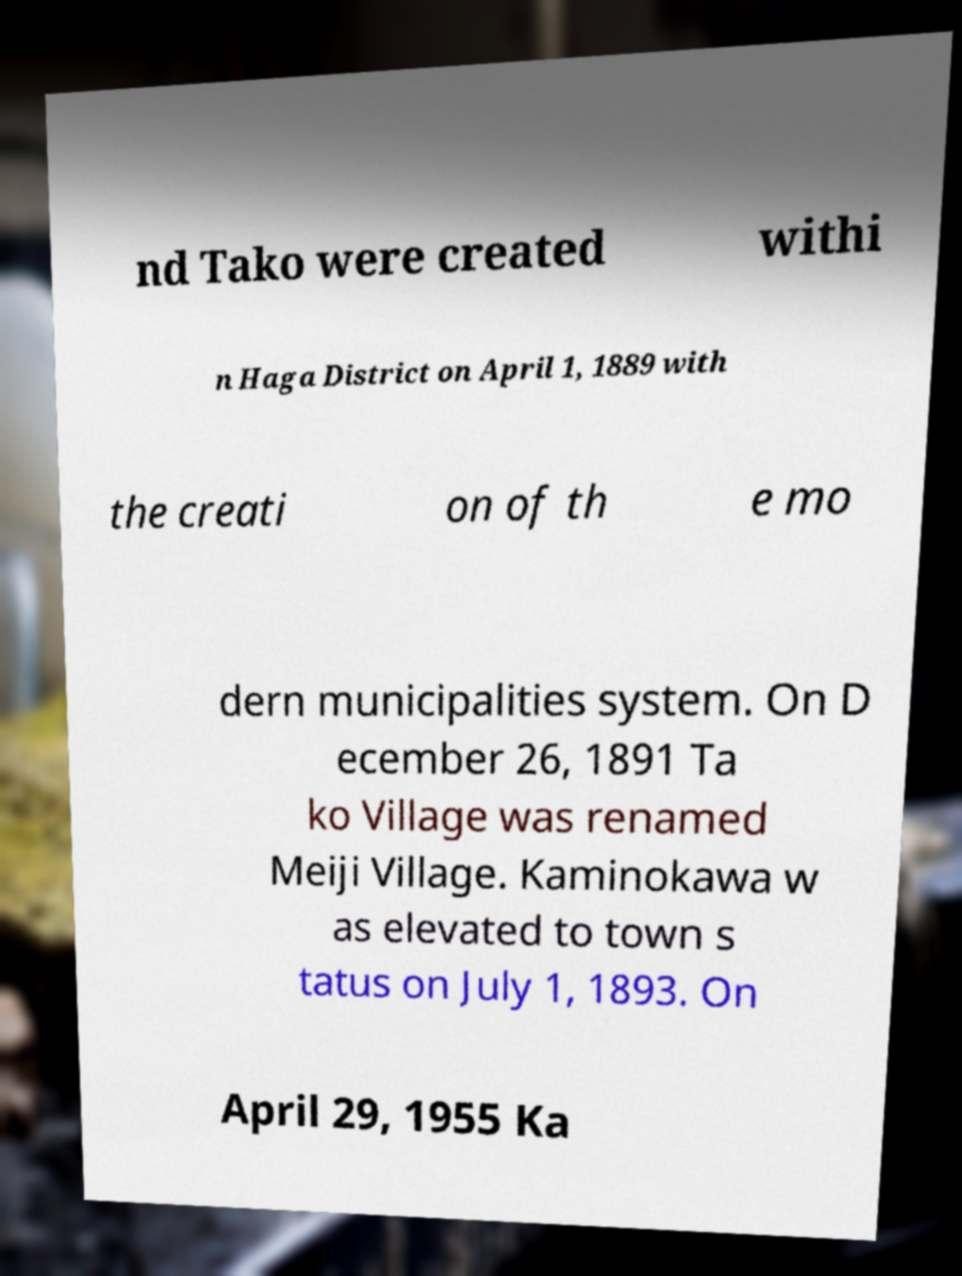For documentation purposes, I need the text within this image transcribed. Could you provide that? nd Tako were created withi n Haga District on April 1, 1889 with the creati on of th e mo dern municipalities system. On D ecember 26, 1891 Ta ko Village was renamed Meiji Village. Kaminokawa w as elevated to town s tatus on July 1, 1893. On April 29, 1955 Ka 